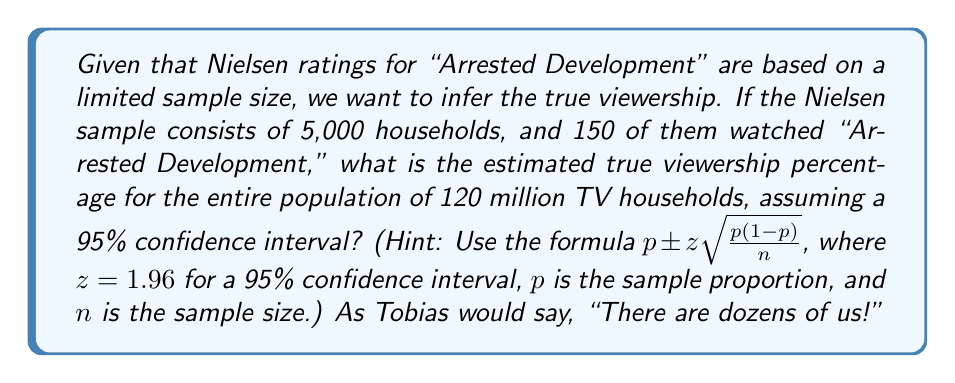Can you solve this math problem? Let's break this down step-by-step:

1. Calculate the sample proportion $p$:
   $p = \frac{150}{5000} = 0.03$ or 3%

2. Identify the values for the confidence interval formula:
   $z = 1.96$ (for 95% confidence interval)
   $n = 5000$ (sample size)
   $p = 0.03$ (sample proportion)

3. Calculate the margin of error:
   $\text{Margin of Error} = z\sqrt{\frac{p(1-p)}{n}}$
   $= 1.96\sqrt{\frac{0.03(1-0.03)}{5000}}$
   $= 1.96\sqrt{\frac{0.0291}{5000}}$
   $= 1.96 \times 0.00241$
   $= 0.00472$ or 0.472%

4. Calculate the confidence interval:
   $\text{Lower bound} = p - \text{Margin of Error} = 0.03 - 0.00472 = 0.02528$ or 2.528%
   $\text{Upper bound} = p + \text{Margin of Error} = 0.03 + 0.00472 = 0.03472$ or 3.472%

5. Interpret the result:
   We can be 95% confident that the true viewership percentage for the entire population of 120 million TV households falls between 2.528% and 3.472%.

As Gob would say, "I've made a huge tiny mistake" if we assumed the sample proportion was exactly representative of the population.
Answer: 2.528% to 3.472% 